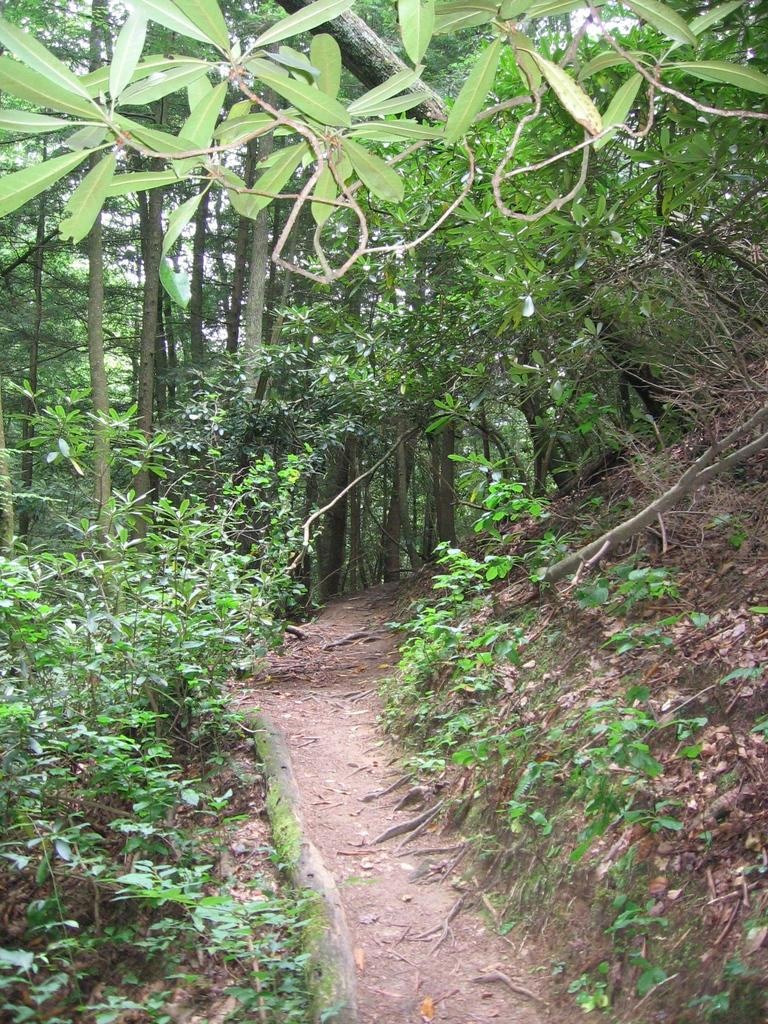What type of vegetation is present in the image? There are many trees, plants, and grass in the image. Can you describe the leaves visible in the image? Yes, there are leaves visible at the top of the image. What part of the natural environment is visible in the image? The sky is visible in the top left corner of the image. What type of thing is flying in the sky in the image? There is no thing flying in the sky in the image; only the leaves and the sky are visible. What class of animal is present in the image? There are no animals present in the image; it features trees, plants, grass, leaves, and the sky. 